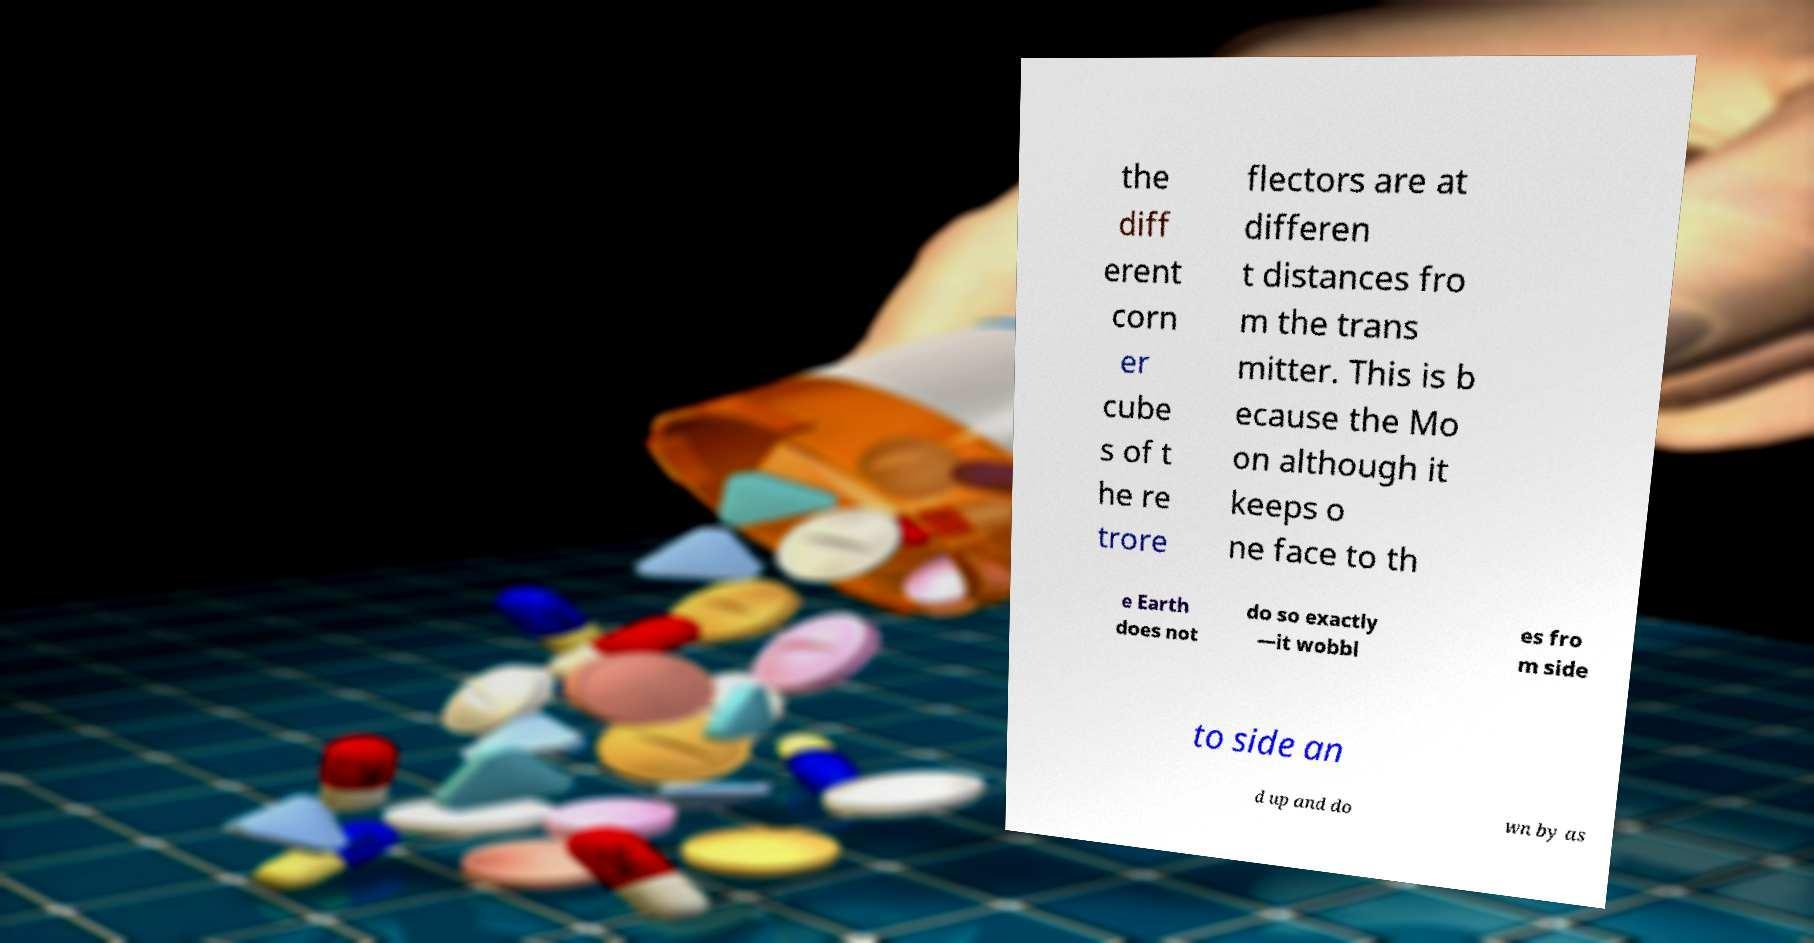Could you extract and type out the text from this image? the diff erent corn er cube s of t he re trore flectors are at differen t distances fro m the trans mitter. This is b ecause the Mo on although it keeps o ne face to th e Earth does not do so exactly —it wobbl es fro m side to side an d up and do wn by as 